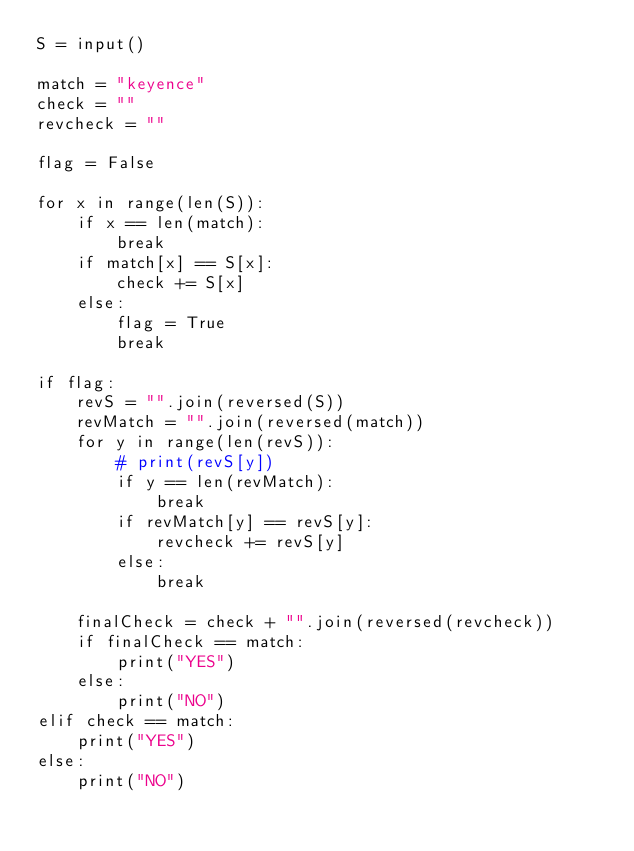<code> <loc_0><loc_0><loc_500><loc_500><_Python_>S = input()

match = "keyence"
check = ""
revcheck = ""

flag = False

for x in range(len(S)):
    if x == len(match):
        break
    if match[x] == S[x]:
        check += S[x]
    else:
        flag = True
        break

if flag:
    revS = "".join(reversed(S))
    revMatch = "".join(reversed(match))
    for y in range(len(revS)):
        # print(revS[y])
        if y == len(revMatch):
            break
        if revMatch[y] == revS[y]:
            revcheck += revS[y]
        else:
            break

    finalCheck = check + "".join(reversed(revcheck))
    if finalCheck == match:
        print("YES")
    else:
        print("NO")
elif check == match:
    print("YES")
else:
    print("NO")
</code> 